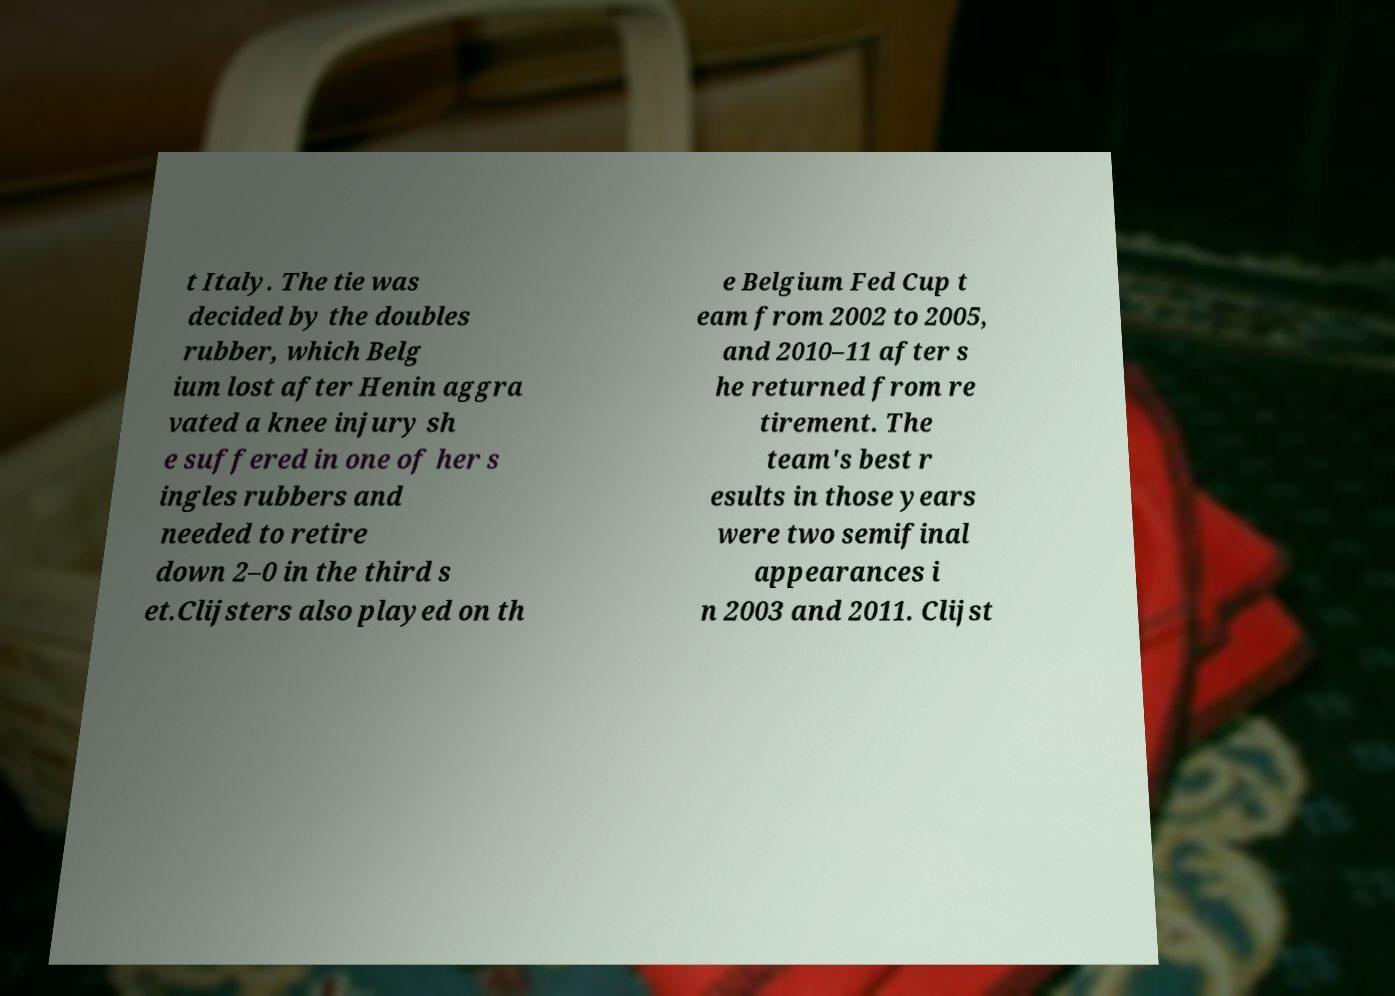I need the written content from this picture converted into text. Can you do that? t Italy. The tie was decided by the doubles rubber, which Belg ium lost after Henin aggra vated a knee injury sh e suffered in one of her s ingles rubbers and needed to retire down 2–0 in the third s et.Clijsters also played on th e Belgium Fed Cup t eam from 2002 to 2005, and 2010–11 after s he returned from re tirement. The team's best r esults in those years were two semifinal appearances i n 2003 and 2011. Clijst 